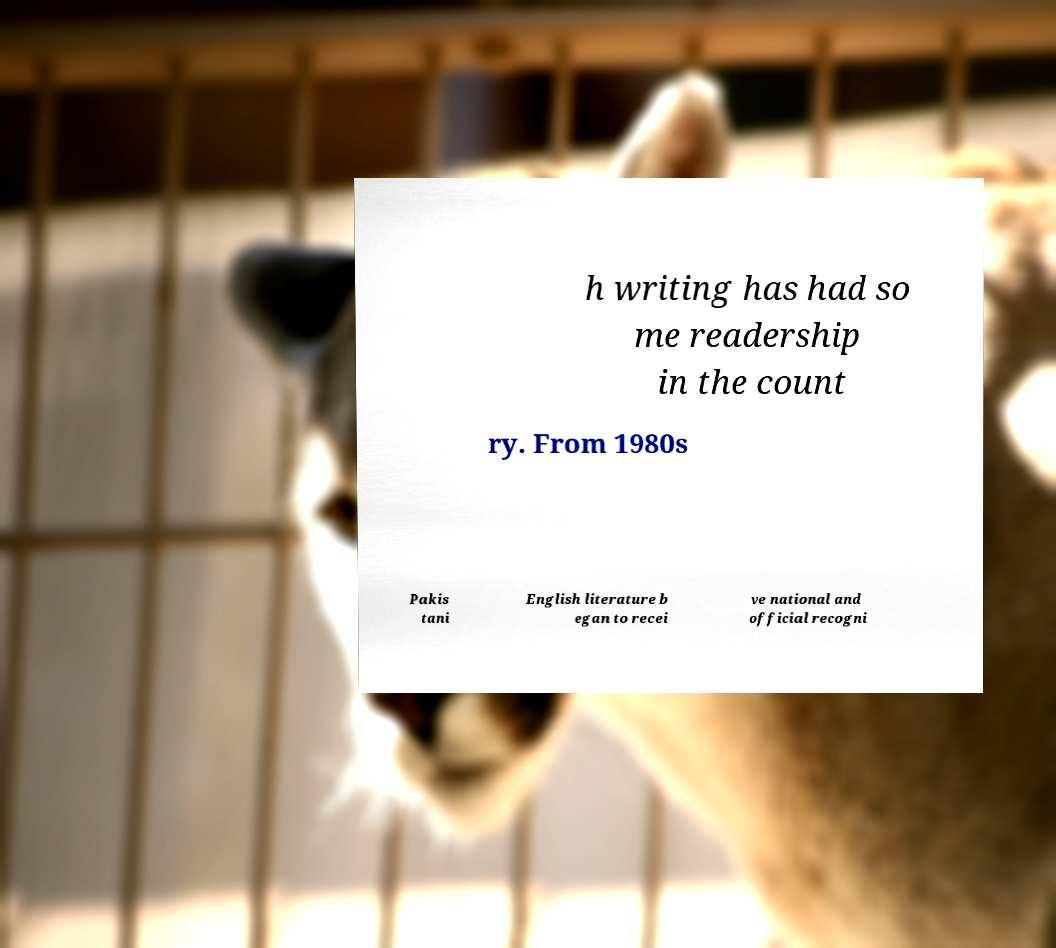Could you assist in decoding the text presented in this image and type it out clearly? h writing has had so me readership in the count ry. From 1980s Pakis tani English literature b egan to recei ve national and official recogni 